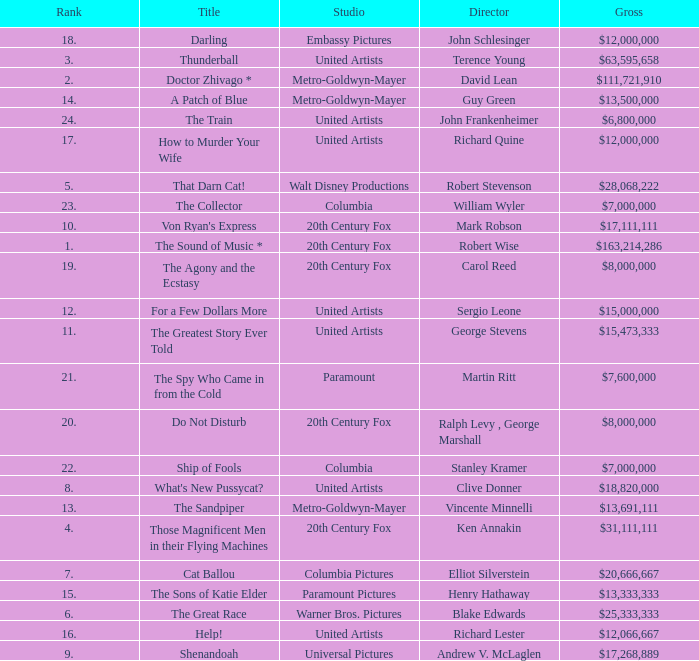Would you be able to parse every entry in this table? {'header': ['Rank', 'Title', 'Studio', 'Director', 'Gross'], 'rows': [['18.', 'Darling', 'Embassy Pictures', 'John Schlesinger', '$12,000,000'], ['3.', 'Thunderball', 'United Artists', 'Terence Young', '$63,595,658'], ['2.', 'Doctor Zhivago *', 'Metro-Goldwyn-Mayer', 'David Lean', '$111,721,910'], ['14.', 'A Patch of Blue', 'Metro-Goldwyn-Mayer', 'Guy Green', '$13,500,000'], ['24.', 'The Train', 'United Artists', 'John Frankenheimer', '$6,800,000'], ['17.', 'How to Murder Your Wife', 'United Artists', 'Richard Quine', '$12,000,000'], ['5.', 'That Darn Cat!', 'Walt Disney Productions', 'Robert Stevenson', '$28,068,222'], ['23.', 'The Collector', 'Columbia', 'William Wyler', '$7,000,000'], ['10.', "Von Ryan's Express", '20th Century Fox', 'Mark Robson', '$17,111,111'], ['1.', 'The Sound of Music *', '20th Century Fox', 'Robert Wise', '$163,214,286'], ['19.', 'The Agony and the Ecstasy', '20th Century Fox', 'Carol Reed', '$8,000,000'], ['12.', 'For a Few Dollars More', 'United Artists', 'Sergio Leone', '$15,000,000'], ['11.', 'The Greatest Story Ever Told', 'United Artists', 'George Stevens', '$15,473,333'], ['21.', 'The Spy Who Came in from the Cold', 'Paramount', 'Martin Ritt', '$7,600,000'], ['20.', 'Do Not Disturb', '20th Century Fox', 'Ralph Levy , George Marshall', '$8,000,000'], ['22.', 'Ship of Fools', 'Columbia', 'Stanley Kramer', '$7,000,000'], ['8.', "What's New Pussycat?", 'United Artists', 'Clive Donner', '$18,820,000'], ['13.', 'The Sandpiper', 'Metro-Goldwyn-Mayer', 'Vincente Minnelli', '$13,691,111'], ['4.', 'Those Magnificent Men in their Flying Machines', '20th Century Fox', 'Ken Annakin', '$31,111,111'], ['7.', 'Cat Ballou', 'Columbia Pictures', 'Elliot Silverstein', '$20,666,667'], ['15.', 'The Sons of Katie Elder', 'Paramount Pictures', 'Henry Hathaway', '$13,333,333'], ['6.', 'The Great Race', 'Warner Bros. Pictures', 'Blake Edwards', '$25,333,333'], ['16.', 'Help!', 'United Artists', 'Richard Lester', '$12,066,667'], ['9.', 'Shenandoah', 'Universal Pictures', 'Andrew V. McLaglen', '$17,268,889']]} What is the highest Rank, when Director is "Henry Hathaway"? 15.0. 